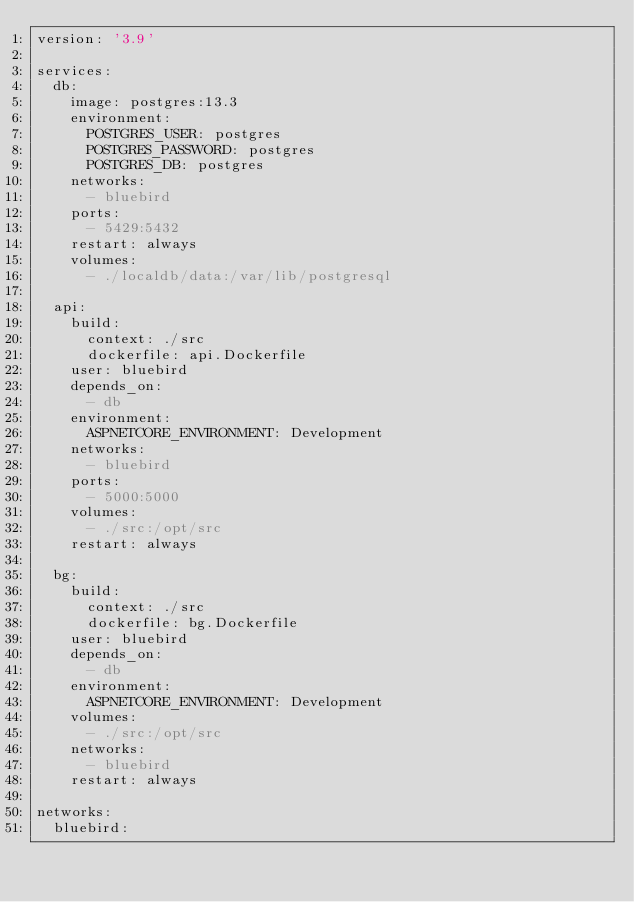Convert code to text. <code><loc_0><loc_0><loc_500><loc_500><_YAML_>version: '3.9'

services:
  db:
    image: postgres:13.3
    environment:
      POSTGRES_USER: postgres
      POSTGRES_PASSWORD: postgres
      POSTGRES_DB: postgres
    networks:
      - bluebird
    ports:
      - 5429:5432
    restart: always
    volumes:
      - ./localdb/data:/var/lib/postgresql
  
  api:
    build:
      context: ./src
      dockerfile: api.Dockerfile
    user: bluebird
    depends_on:
      - db
    environment:
      ASPNETCORE_ENVIRONMENT: Development
    networks:
      - bluebird
    ports:
      - 5000:5000
    volumes:
      - ./src:/opt/src
    restart: always
  
  bg:
    build:
      context: ./src
      dockerfile: bg.Dockerfile
    user: bluebird
    depends_on:
      - db
    environment:
      ASPNETCORE_ENVIRONMENT: Development
    volumes:
      - ./src:/opt/src
    networks:
      - bluebird
    restart: always

networks:
  bluebird:</code> 